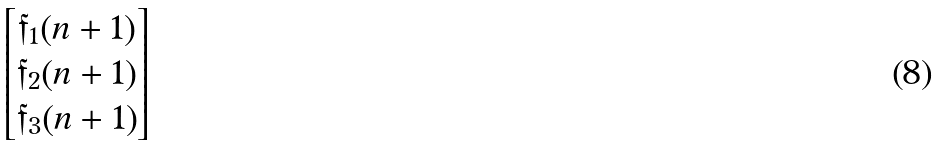Convert formula to latex. <formula><loc_0><loc_0><loc_500><loc_500>\begin{bmatrix} \mathfrak { f } _ { 1 } ( n + 1 ) \\ \mathfrak { f } _ { 2 } ( n + 1 ) \\ \mathfrak { f } _ { 3 } ( n + 1 ) \end{bmatrix}</formula> 